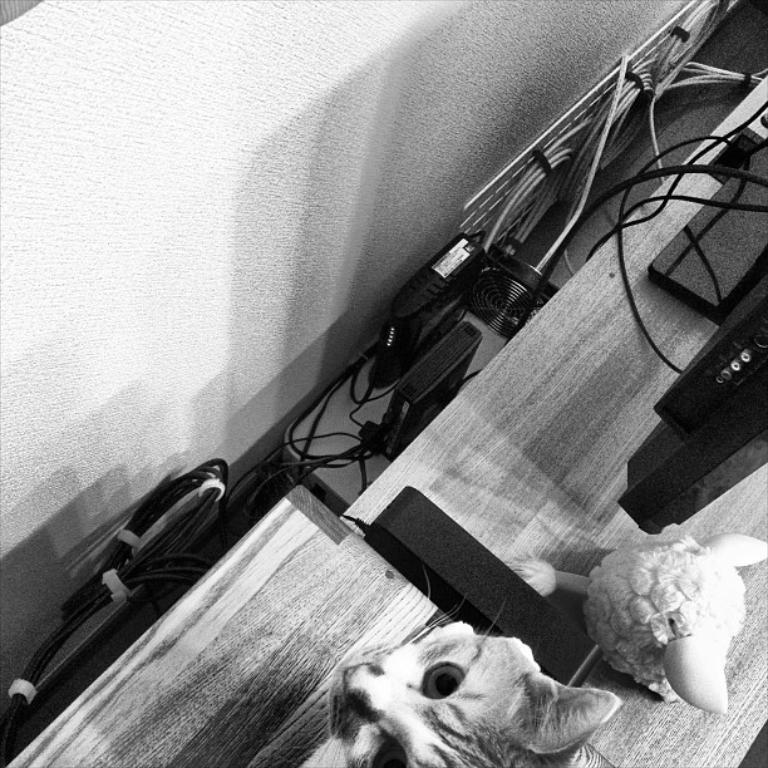What type of animal is present in the image? There is a cat in the image. What other object can be seen in the image? There is a doll in the image. What electronic device is visible in the image? There is a monitor in the image. What accessory is present for the monitor? There is an adapter in the image. What are the cords used for in the image? The cables in the image are used to connect the electronic devices. Where are the objects located in the image? The objects are on a table. What additional device is present behind the table? There is a router behind the table. What is connected to the router? There are more cables behind the router. What is the background behind the router and cables? There is a wall behind the router and cables. What type of glove is the cat wearing in the image? There is no glove present in the image, and the cat is not wearing any clothing. How many feet does the doll have in the image? The image does not show the doll's feet, as only the upper part of the doll is visible. 